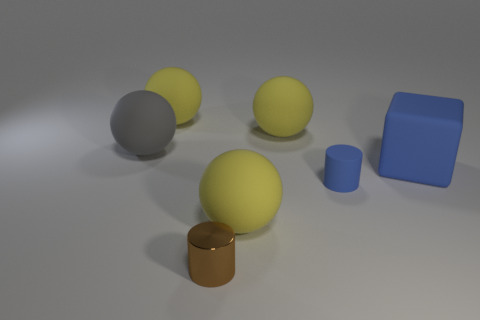Are there any other things that have the same material as the brown cylinder?
Provide a succinct answer. No. Are there any other things that are the same shape as the big blue rubber object?
Ensure brevity in your answer.  No. There is a gray matte thing; is its size the same as the cylinder behind the small brown metallic thing?
Offer a very short reply. No. There is a brown cylinder in front of the large gray rubber ball; what material is it?
Keep it short and to the point. Metal. What color is the cylinder that is the same material as the big gray sphere?
Ensure brevity in your answer.  Blue. What number of rubber things are either yellow things or blocks?
Provide a succinct answer. 4. What shape is the gray object that is the same size as the blue cube?
Give a very brief answer. Sphere. What number of objects are either objects behind the small shiny object or big rubber spheres behind the big block?
Provide a succinct answer. 6. There is another thing that is the same size as the brown metal thing; what is it made of?
Keep it short and to the point. Rubber. What number of other things are there of the same material as the small brown thing
Offer a terse response. 0. 